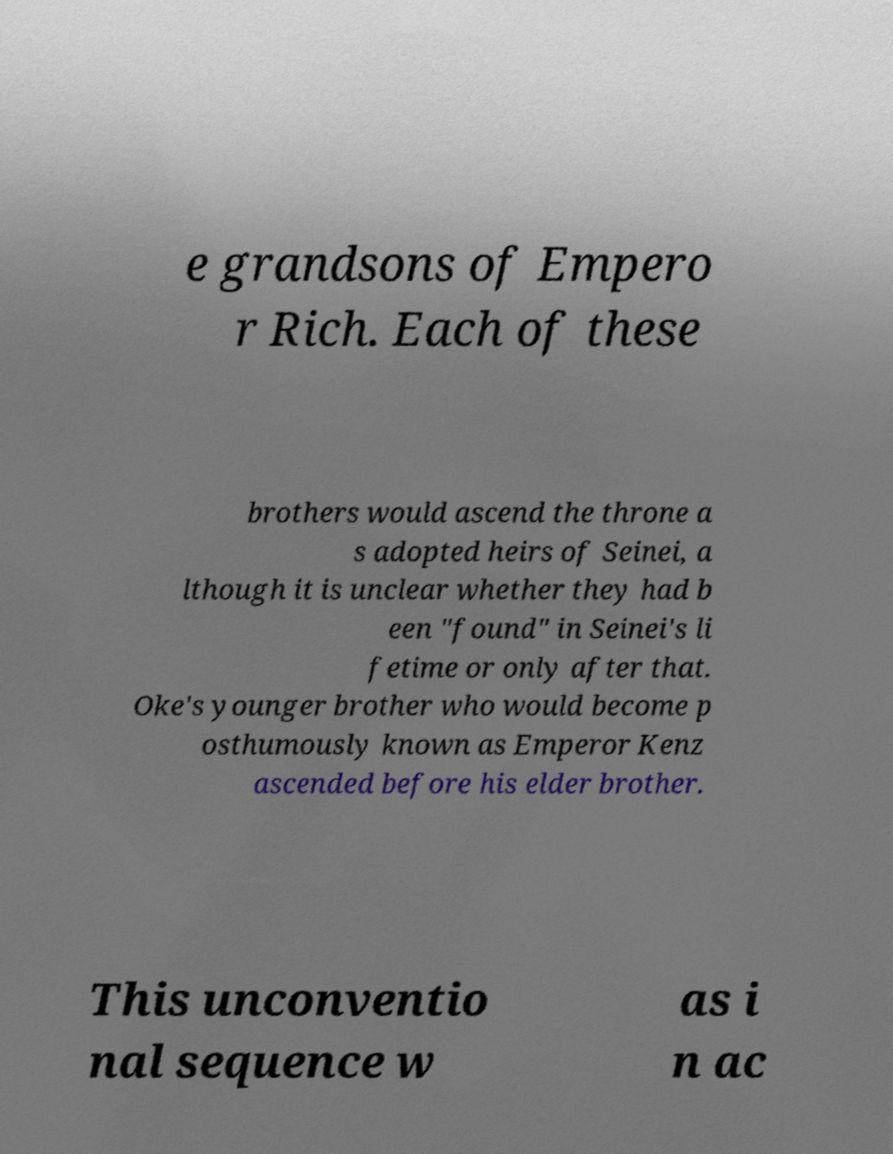Please read and relay the text visible in this image. What does it say? e grandsons of Empero r Rich. Each of these brothers would ascend the throne a s adopted heirs of Seinei, a lthough it is unclear whether they had b een "found" in Seinei's li fetime or only after that. Oke's younger brother who would become p osthumously known as Emperor Kenz ascended before his elder brother. This unconventio nal sequence w as i n ac 